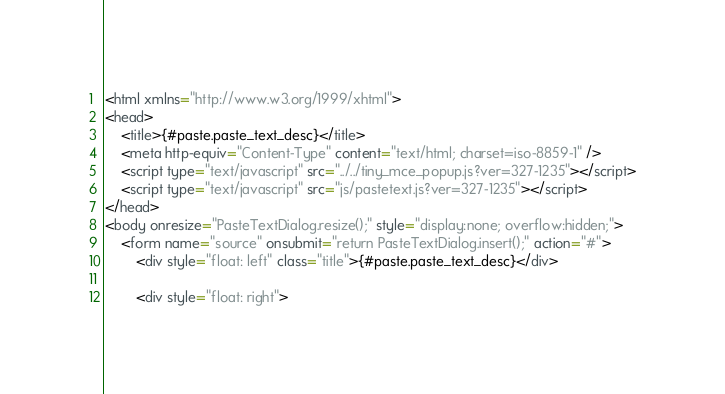Convert code to text. <code><loc_0><loc_0><loc_500><loc_500><_HTML_><html xmlns="http://www.w3.org/1999/xhtml">
<head>
	<title>{#paste.paste_text_desc}</title>
	<meta http-equiv="Content-Type" content="text/html; charset=iso-8859-1" />
	<script type="text/javascript" src="../../tiny_mce_popup.js?ver=327-1235"></script>
	<script type="text/javascript" src="js/pastetext.js?ver=327-1235"></script>
</head>
<body onresize="PasteTextDialog.resize();" style="display:none; overflow:hidden;">
	<form name="source" onsubmit="return PasteTextDialog.insert();" action="#">
		<div style="float: left" class="title">{#paste.paste_text_desc}</div>

		<div style="float: right"></code> 